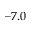Convert formula to latex. <formula><loc_0><loc_0><loc_500><loc_500>- 7 . 0</formula> 